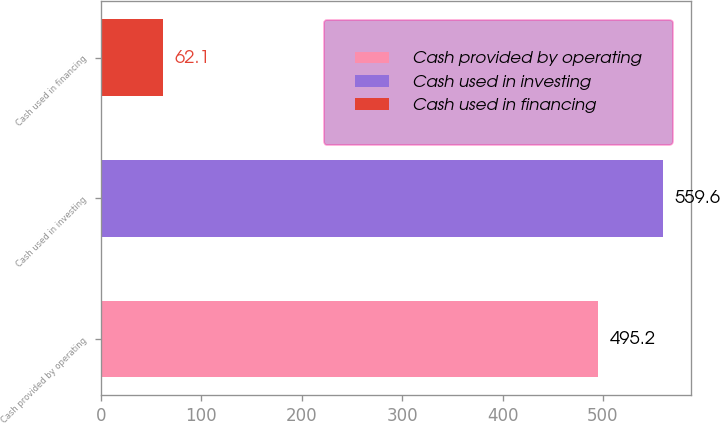<chart> <loc_0><loc_0><loc_500><loc_500><bar_chart><fcel>Cash provided by operating<fcel>Cash used in investing<fcel>Cash used in financing<nl><fcel>495.2<fcel>559.6<fcel>62.1<nl></chart> 